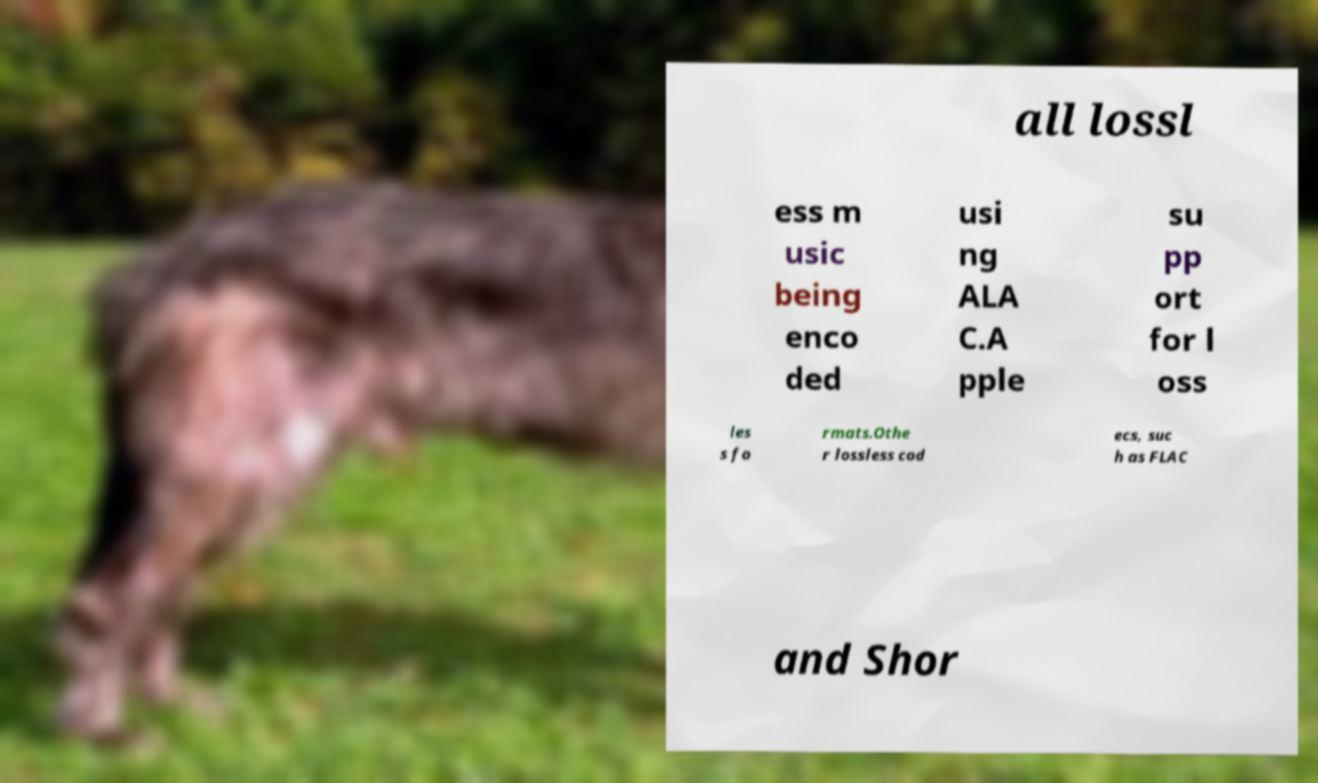There's text embedded in this image that I need extracted. Can you transcribe it verbatim? all lossl ess m usic being enco ded usi ng ALA C.A pple su pp ort for l oss les s fo rmats.Othe r lossless cod ecs, suc h as FLAC and Shor 